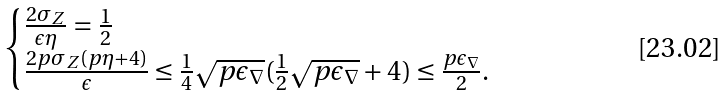<formula> <loc_0><loc_0><loc_500><loc_500>\begin{cases} \frac { 2 \sigma _ { Z } } { \epsilon \eta } = \frac { 1 } { 2 } \\ \frac { 2 p \sigma _ { Z } ( p \eta + 4 ) } { \epsilon } \leq \frac { 1 } { 4 } \sqrt { p \epsilon _ { \nabla } } ( \frac { 1 } { 2 } \sqrt { p \epsilon _ { \nabla } } + 4 ) \leq \frac { p \epsilon _ { \nabla } } { 2 } . \end{cases}</formula> 